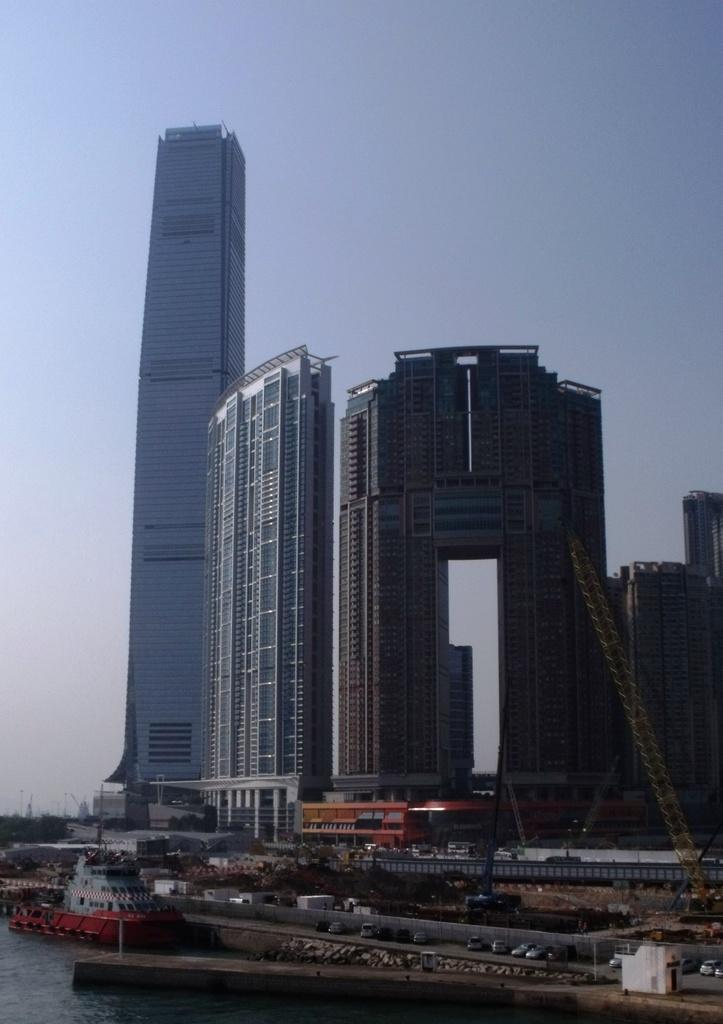What type of structures can be seen in the image? There are buildings in the image. What natural feature is on the left side of the image? There is a river on the left side of the image. What is floating on the water in the image? A ship is floating on the water in the image. What can be seen in the background of the image? There is a sky visible in the background of the image. Can you see any friends or squirrels in the image? There are no friends or squirrels present in the image. What type of hope is depicted in the image? There is no depiction of hope in the image; it features buildings, a river, a ship, and a sky. 